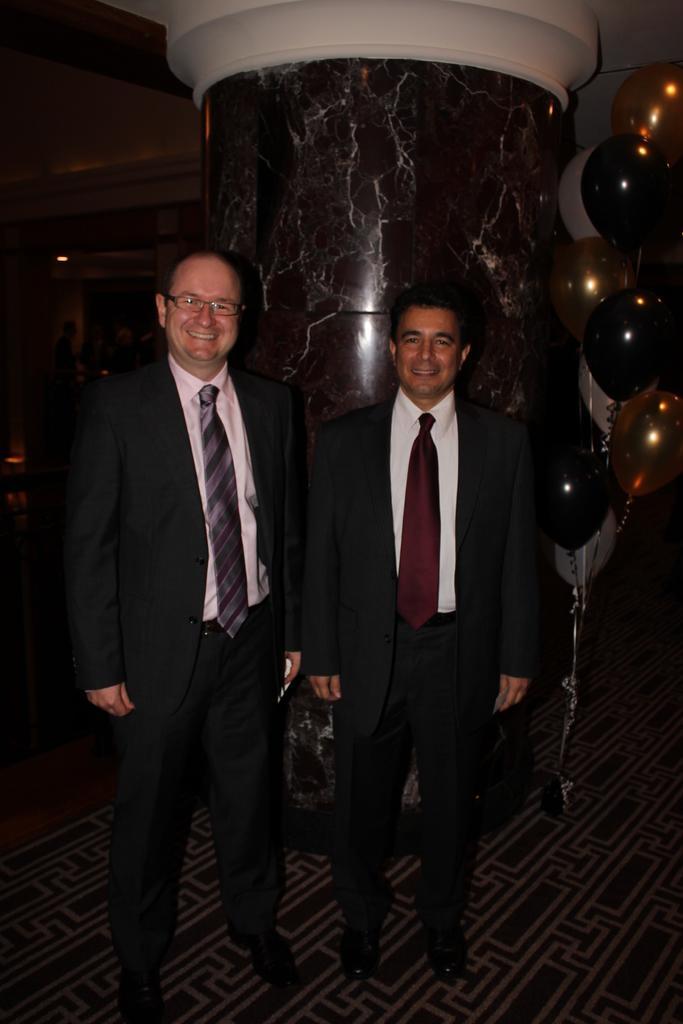In one or two sentences, can you explain what this image depicts? In the center of the image, we can see people wearing coats and ties and one of them is wearing glasses. In the background, there are balloons and we can see some lights and there is a pillar. At the bottom, there is a floor. 